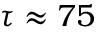<formula> <loc_0><loc_0><loc_500><loc_500>\tau \approx 7 5</formula> 